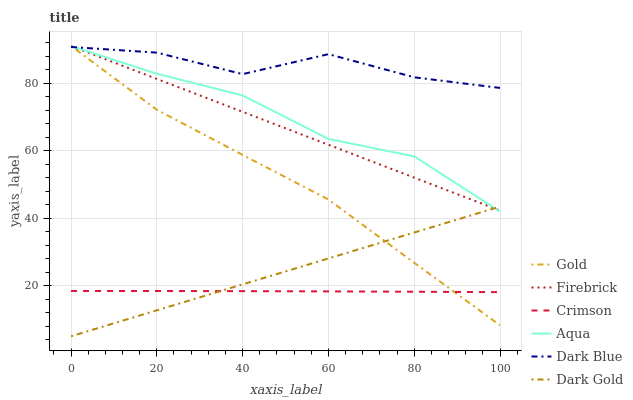Does Dark Gold have the minimum area under the curve?
Answer yes or no. No. Does Dark Gold have the maximum area under the curve?
Answer yes or no. No. Is Dark Gold the smoothest?
Answer yes or no. No. Is Dark Gold the roughest?
Answer yes or no. No. Does Firebrick have the lowest value?
Answer yes or no. No. Does Dark Gold have the highest value?
Answer yes or no. No. Is Crimson less than Aqua?
Answer yes or no. Yes. Is Aqua greater than Crimson?
Answer yes or no. Yes. Does Crimson intersect Aqua?
Answer yes or no. No. 